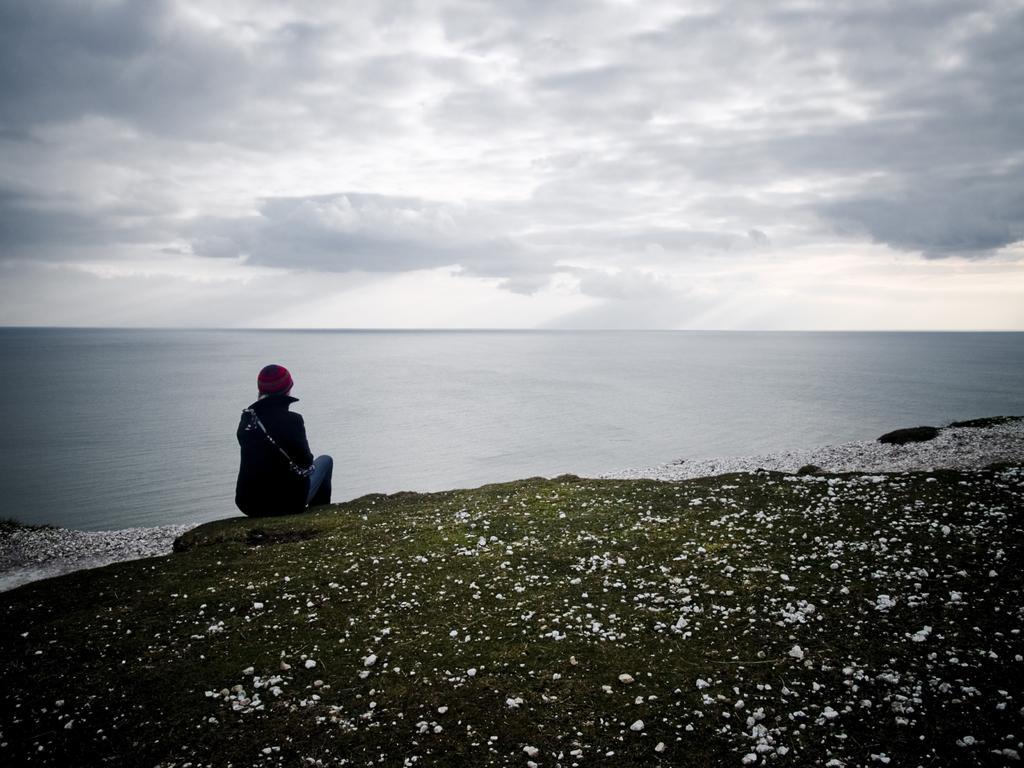Can you describe this image briefly? In this image a person is sitting on the ground. In the background there is water body. The sky is cloudy. On the ground there are stones. 